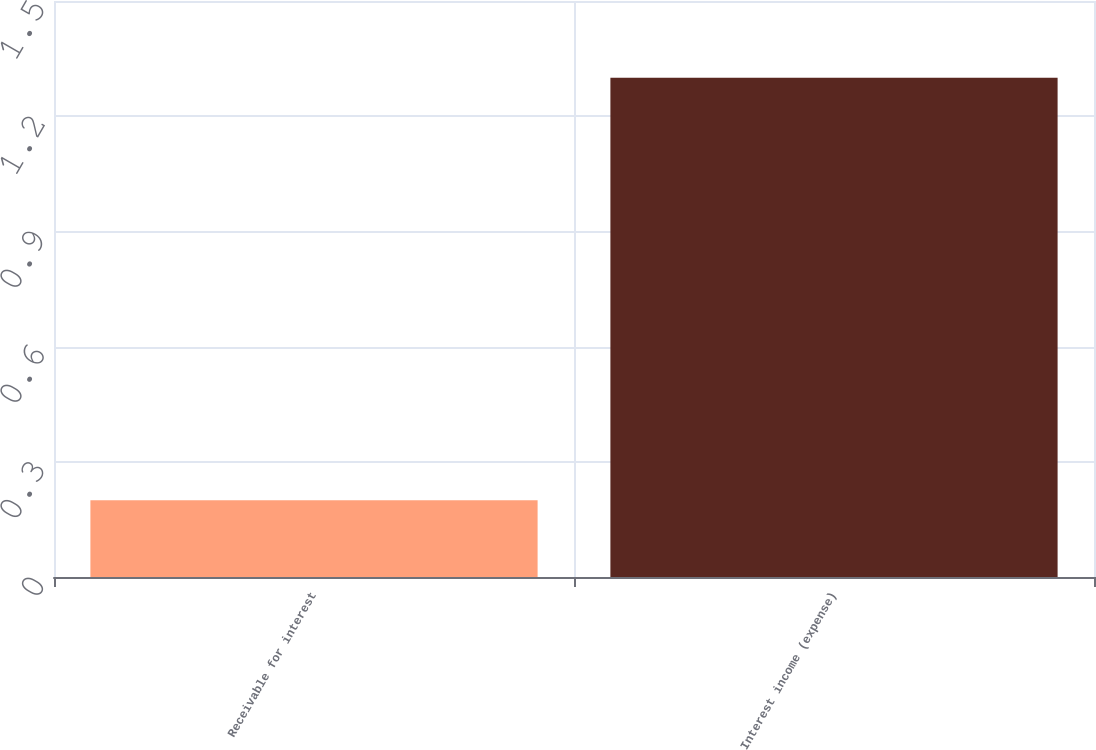Convert chart. <chart><loc_0><loc_0><loc_500><loc_500><bar_chart><fcel>Receivable for interest<fcel>Interest income (expense)<nl><fcel>0.2<fcel>1.3<nl></chart> 